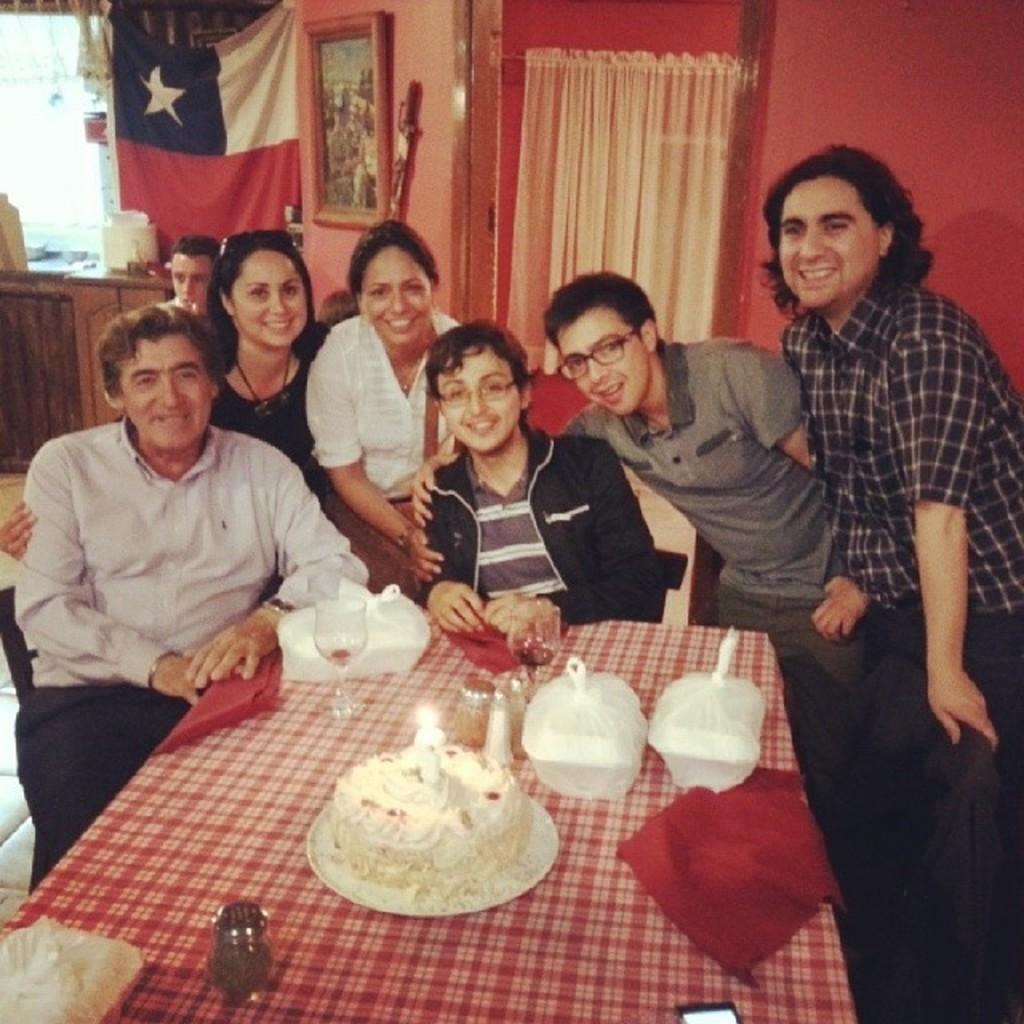In one or two sentences, can you explain what this image depicts? In this image there are a few people sitting on chairs, behind them there are a few people standing, in front of them on the table there are some objects, behind them on the wall there are photo frames and a flag, between the wall there is a curtain on the door and some objects on the wall, on the sink platform there are some objects, beneath that there are cupboards, behind the sink there is a glass window with a curtain on it. 